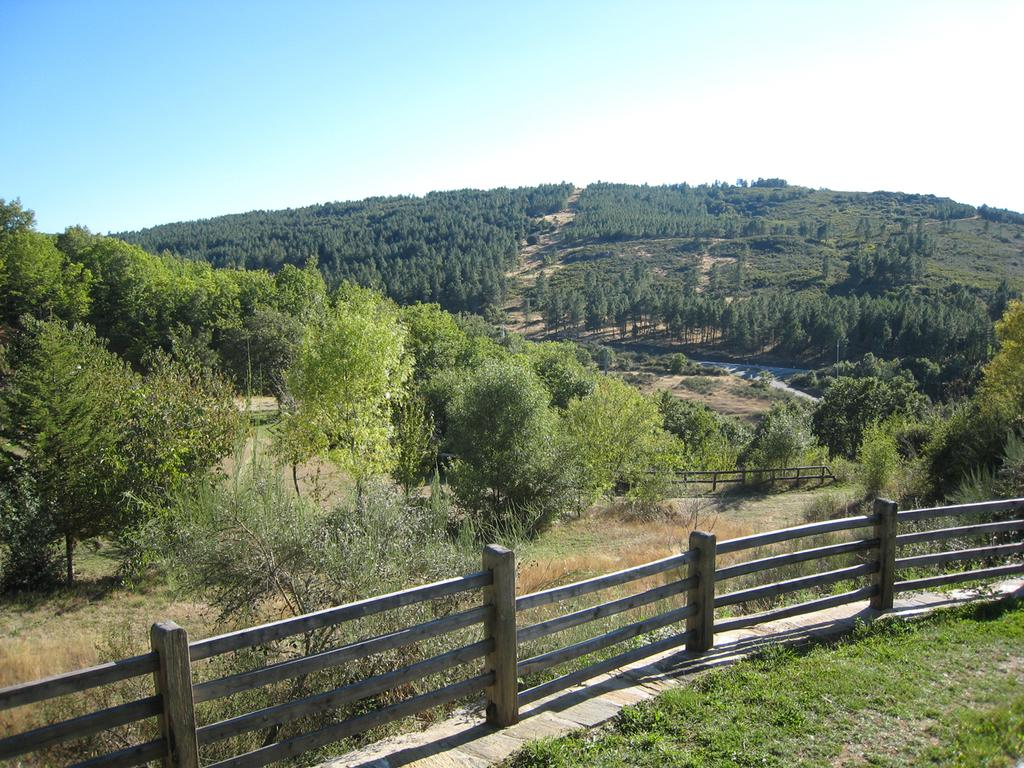What can be seen at the bottom of the picture? There is railing in the bottom of the picture. What type of natural elements are visible in the background of the picture? There are trees in the background of the picture. What part of the natural environment is visible in the background of the picture? The sky is visible in the background of the picture. What type of drink is being offered to the zebra in the image? There is no zebra present in the image, and therefore no drink being offered. 